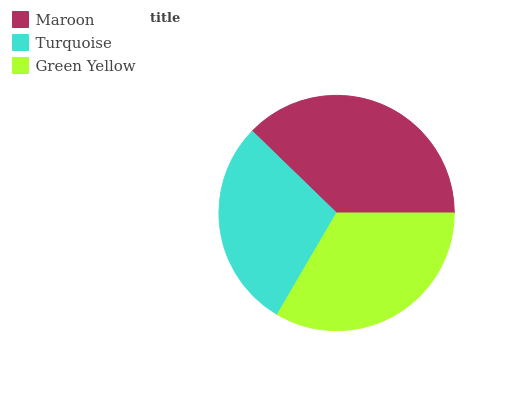Is Turquoise the minimum?
Answer yes or no. Yes. Is Maroon the maximum?
Answer yes or no. Yes. Is Green Yellow the minimum?
Answer yes or no. No. Is Green Yellow the maximum?
Answer yes or no. No. Is Green Yellow greater than Turquoise?
Answer yes or no. Yes. Is Turquoise less than Green Yellow?
Answer yes or no. Yes. Is Turquoise greater than Green Yellow?
Answer yes or no. No. Is Green Yellow less than Turquoise?
Answer yes or no. No. Is Green Yellow the high median?
Answer yes or no. Yes. Is Green Yellow the low median?
Answer yes or no. Yes. Is Turquoise the high median?
Answer yes or no. No. Is Maroon the low median?
Answer yes or no. No. 